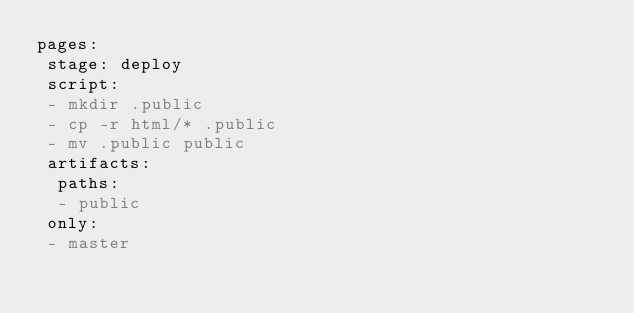<code> <loc_0><loc_0><loc_500><loc_500><_YAML_>pages:
 stage: deploy
 script:
 - mkdir .public
 - cp -r html/* .public
 - mv .public public
 artifacts:
  paths:
  - public
 only:
 - master

</code> 